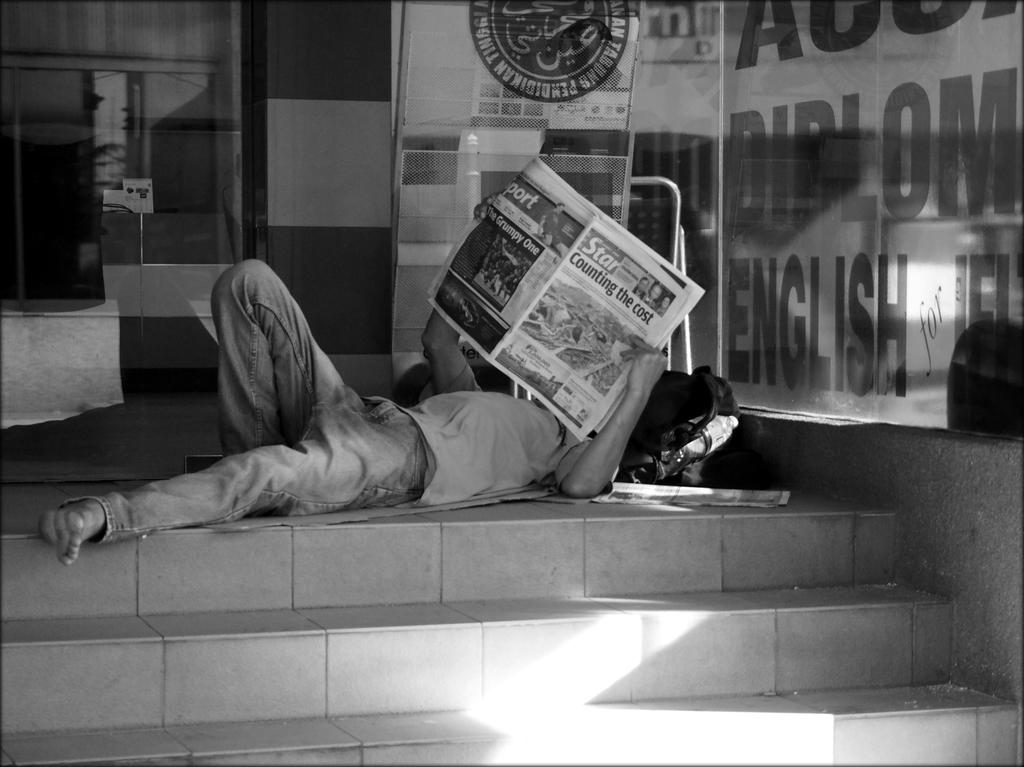What is the main subject of the image? There is a person in the image. What objects can be seen with the person? There is a bag, a bottle, and a glass with some text in the image. Are there any architectural features in the image? Yes, there are steps in the image. What is the person holding? The person is holding a newspaper. What type of heart can be seen beating in the image? There is no heart visible in the image. Can you describe the ghost that is haunting the person in the image? There is no ghost present in the image. 